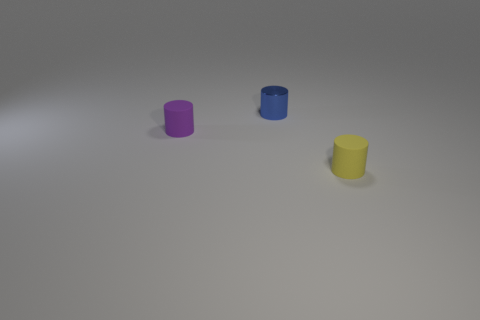Add 1 big blue metal cubes. How many objects exist? 4 Add 2 blue metallic objects. How many blue metallic objects are left? 3 Add 3 cylinders. How many cylinders exist? 6 Subtract 0 purple blocks. How many objects are left? 3 Subtract all tiny blue metal cylinders. Subtract all tiny brown metallic objects. How many objects are left? 2 